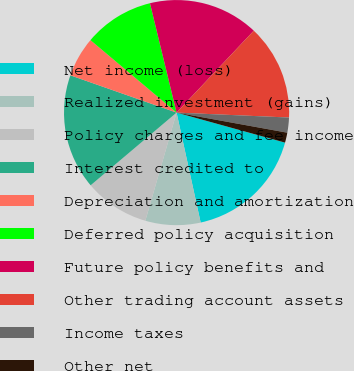<chart> <loc_0><loc_0><loc_500><loc_500><pie_chart><fcel>Net income (loss)<fcel>Realized investment (gains)<fcel>Policy charges and fee income<fcel>Interest credited to<fcel>Depreciation and amortization<fcel>Deferred policy acquisition<fcel>Future policy benefits and<fcel>Other trading account assets<fcel>Income taxes<fcel>Other net<nl><fcel>17.27%<fcel>7.91%<fcel>9.35%<fcel>16.55%<fcel>5.76%<fcel>10.07%<fcel>15.83%<fcel>13.67%<fcel>2.16%<fcel>1.44%<nl></chart> 